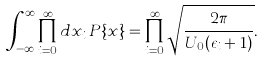Convert formula to latex. <formula><loc_0><loc_0><loc_500><loc_500>\int _ { - \infty } ^ { \infty } \prod _ { i = 0 } ^ { \infty } d x _ { i } \, P \{ x \} = \prod _ { i = 0 } ^ { \infty } \sqrt { \frac { 2 \pi } { U _ { 0 } ( \epsilon _ { i } + 1 ) } } .</formula> 